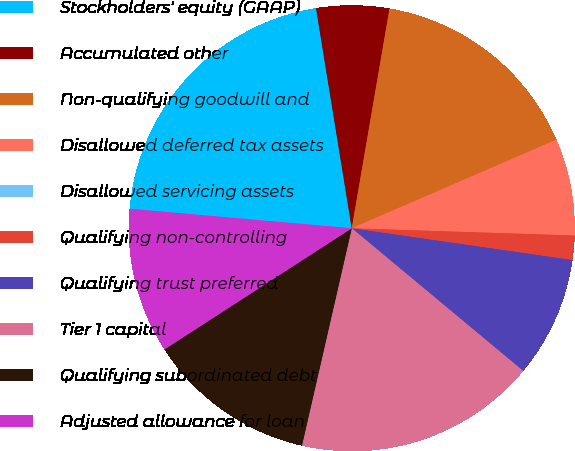<chart> <loc_0><loc_0><loc_500><loc_500><pie_chart><fcel>Stockholders' equity (GAAP)<fcel>Accumulated other<fcel>Non-qualifying goodwill and<fcel>Disallowed deferred tax assets<fcel>Disallowed servicing assets<fcel>Qualifying non-controlling<fcel>Qualifying trust preferred<fcel>Tier 1 capital<fcel>Qualifying subordinated debt<fcel>Adjusted allowance for loan<nl><fcel>21.05%<fcel>5.27%<fcel>15.79%<fcel>7.02%<fcel>0.0%<fcel>1.76%<fcel>8.77%<fcel>17.54%<fcel>12.28%<fcel>10.53%<nl></chart> 